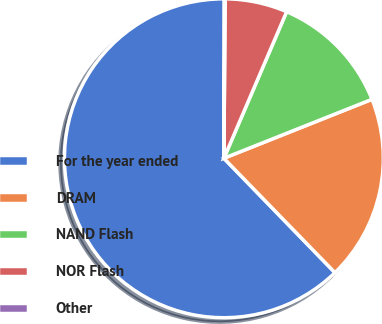Convert chart to OTSL. <chart><loc_0><loc_0><loc_500><loc_500><pie_chart><fcel>For the year ended<fcel>DRAM<fcel>NAND Flash<fcel>NOR Flash<fcel>Other<nl><fcel>62.3%<fcel>18.76%<fcel>12.53%<fcel>6.31%<fcel>0.09%<nl></chart> 